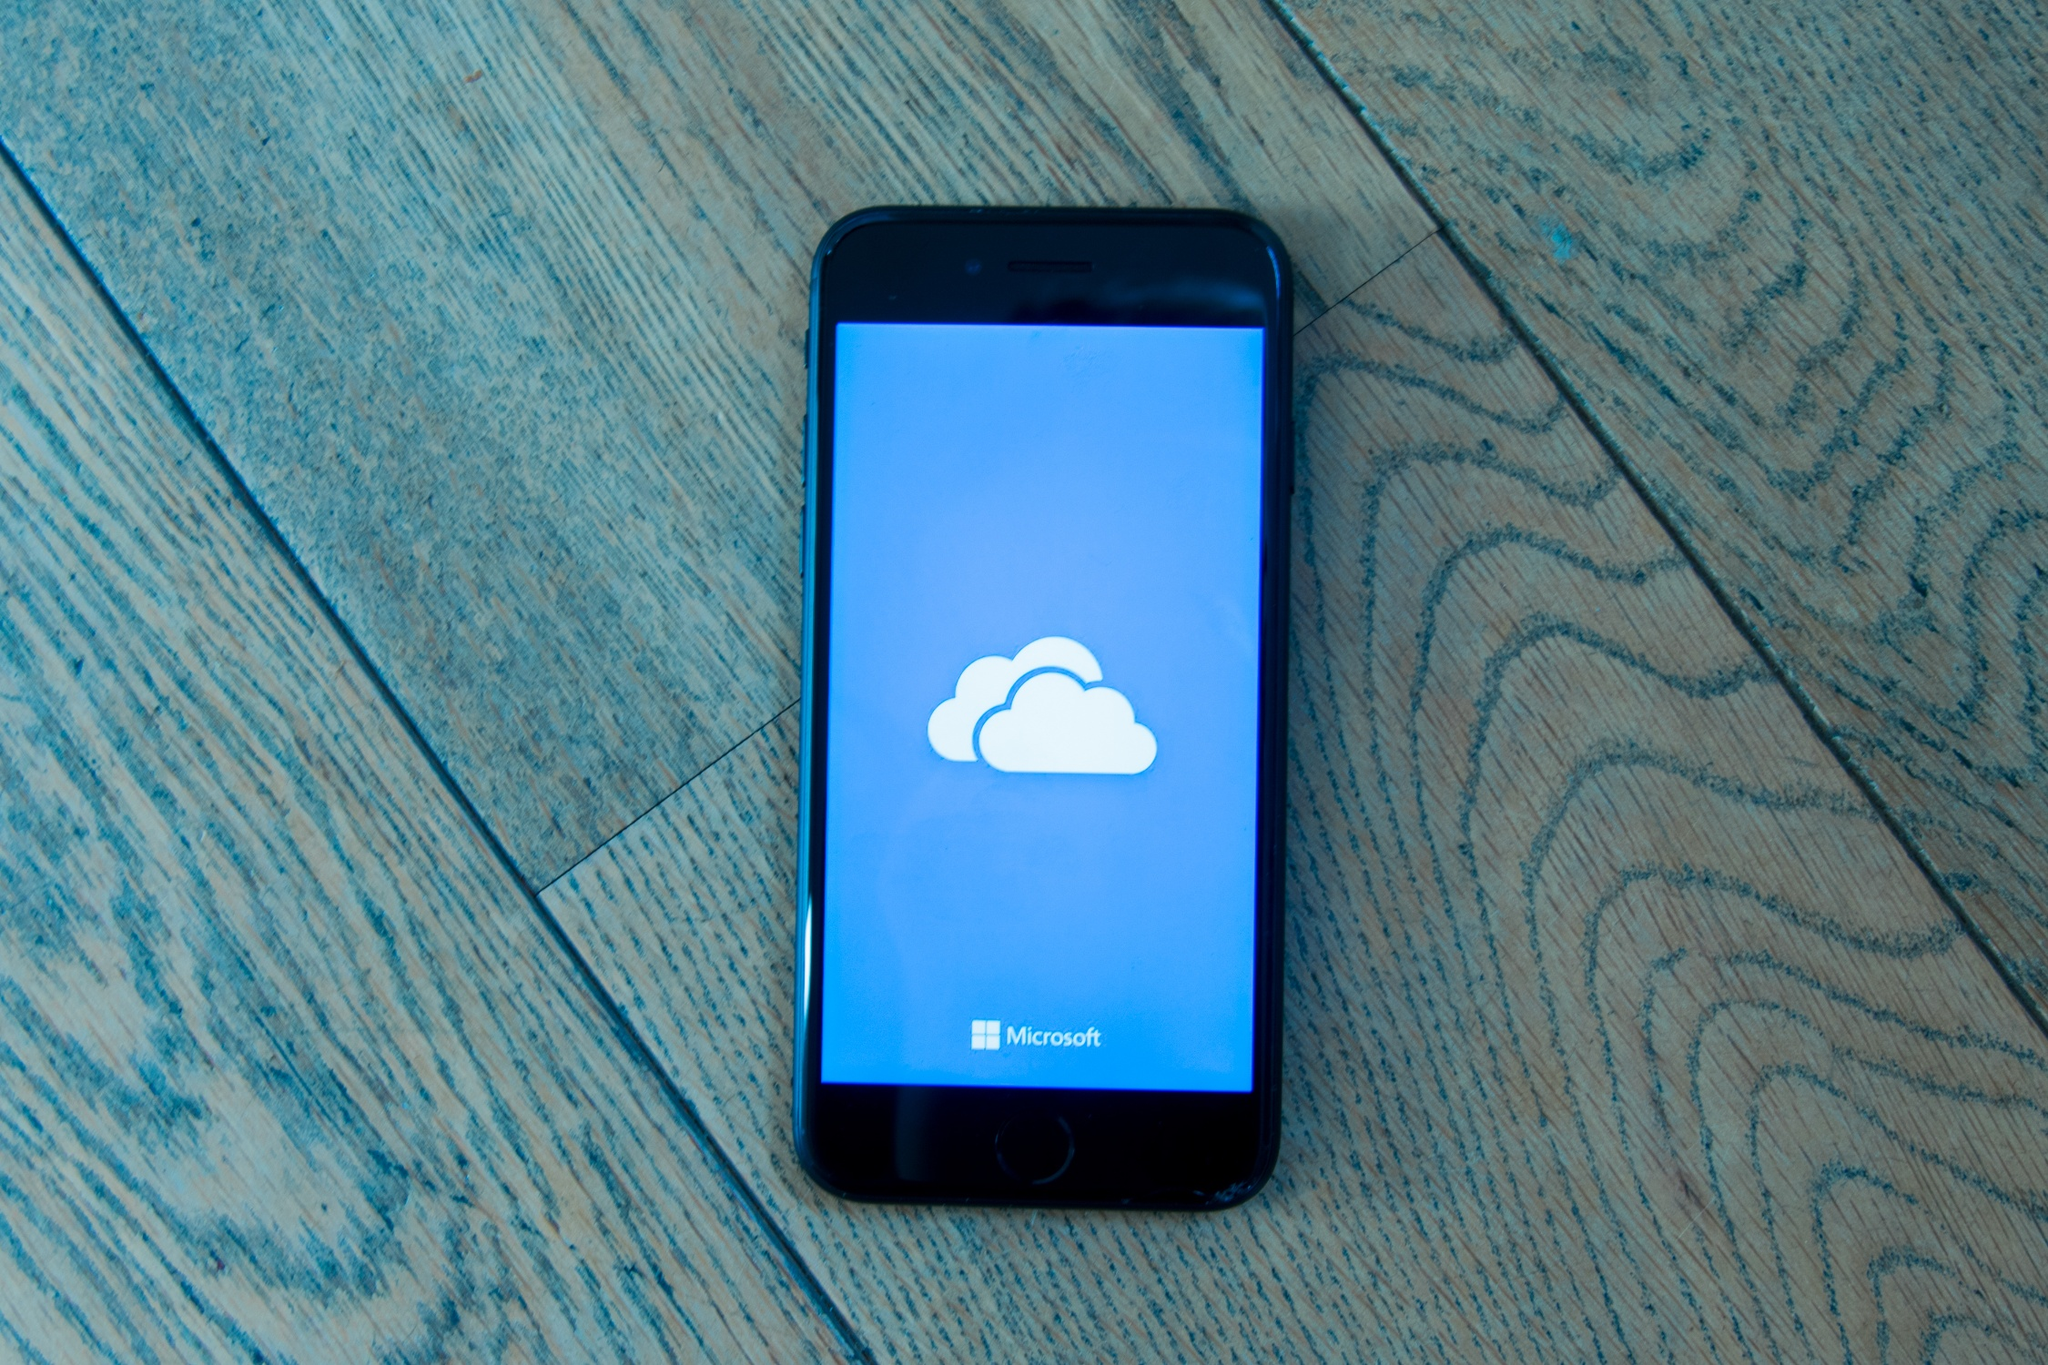What practical scenario might have led to the phone being placed on the floor in this manner? A practical scenario could involve someone accidentally dropping their phone while juggling multiple tasks. Perhaps they were in a hurry to respond to a message or update, and the phone slipped from their hand, landing diagonally on the floor. The immediate need to address other pressing matters might have caused them to leave it temporarily, resulting in this spontaneous and casually placed scene. What means might someone have been doing to use the phone in such a situation? It's likely that someone was using their phone for a task such as checking emails, uploading files to the cloud, or communicating with someone through a messaging app. They might have been uploading important documents to Microsoft's cloud storage, interrupted by an unexpected event or an urgent task that required them to place the phone on the floor quickly and continue with their activity. The illuminated screen with the cloud icon suggests the phone was actively engaged in a process related to data storage or transfer. 